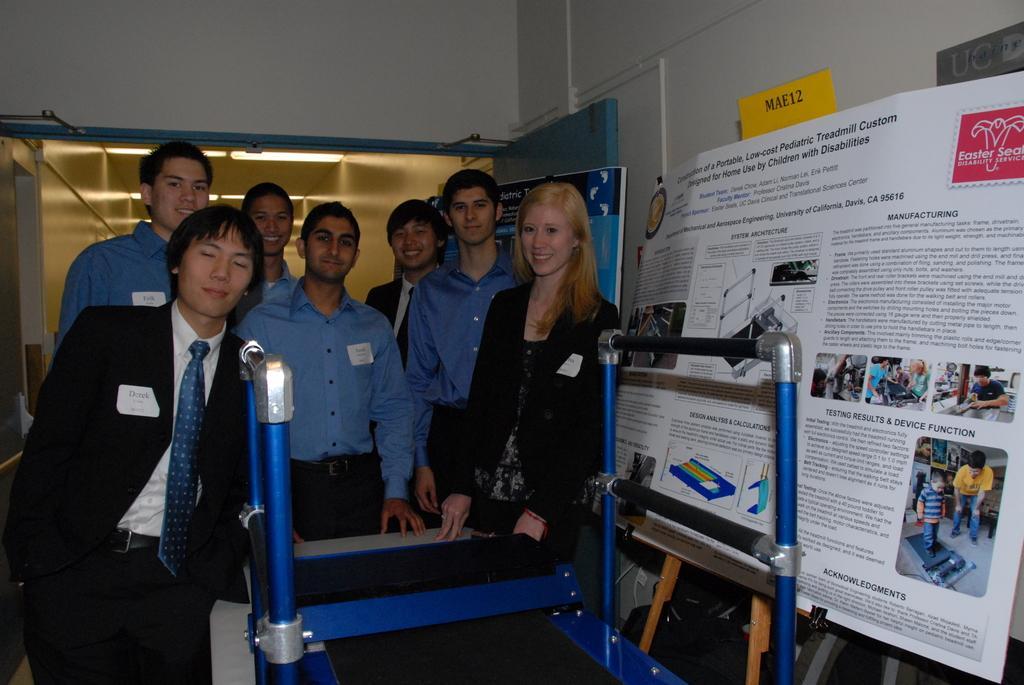In one or two sentences, can you explain what this image depicts? In this picture we can see a group of people standing and smiling and some of them wore blazers, ties and stickers on them, rods, banners, name board, door, lights, walls and some objects. 